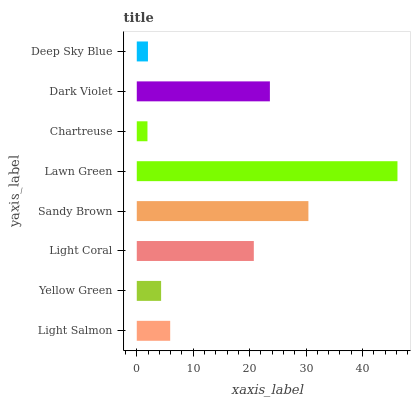Is Chartreuse the minimum?
Answer yes or no. Yes. Is Lawn Green the maximum?
Answer yes or no. Yes. Is Yellow Green the minimum?
Answer yes or no. No. Is Yellow Green the maximum?
Answer yes or no. No. Is Light Salmon greater than Yellow Green?
Answer yes or no. Yes. Is Yellow Green less than Light Salmon?
Answer yes or no. Yes. Is Yellow Green greater than Light Salmon?
Answer yes or no. No. Is Light Salmon less than Yellow Green?
Answer yes or no. No. Is Light Coral the high median?
Answer yes or no. Yes. Is Light Salmon the low median?
Answer yes or no. Yes. Is Light Salmon the high median?
Answer yes or no. No. Is Sandy Brown the low median?
Answer yes or no. No. 